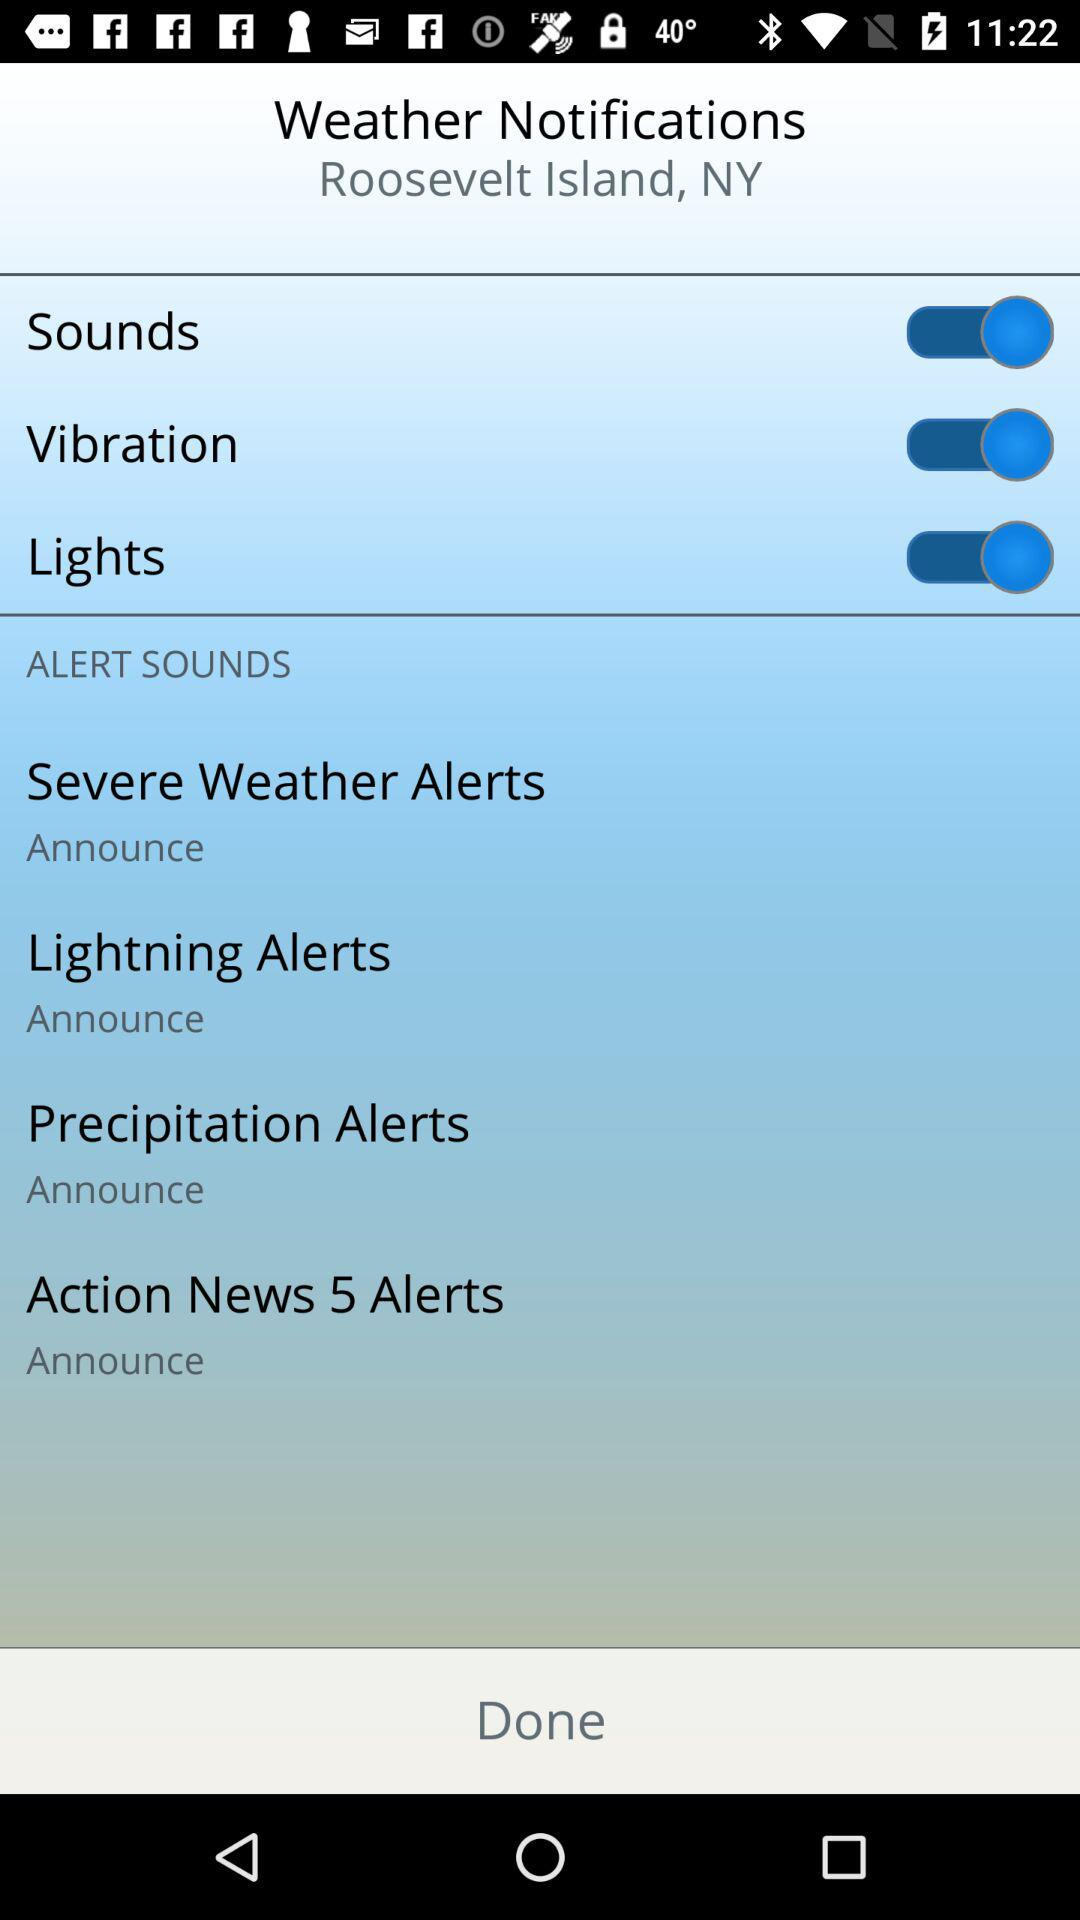How many alert sounds are available?
Answer the question using a single word or phrase. 4 